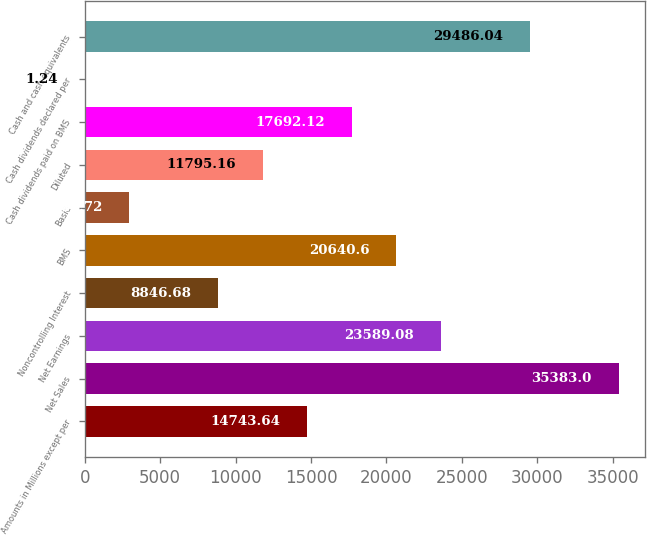Convert chart. <chart><loc_0><loc_0><loc_500><loc_500><bar_chart><fcel>Amounts in Millions except per<fcel>Net Sales<fcel>Net Earnings<fcel>Noncontrolling Interest<fcel>BMS<fcel>Basic<fcel>Diluted<fcel>Cash dividends paid on BMS<fcel>Cash dividends declared per<fcel>Cash and cash equivalents<nl><fcel>14743.6<fcel>35383<fcel>23589.1<fcel>8846.68<fcel>20640.6<fcel>2949.72<fcel>11795.2<fcel>17692.1<fcel>1.24<fcel>29486<nl></chart> 